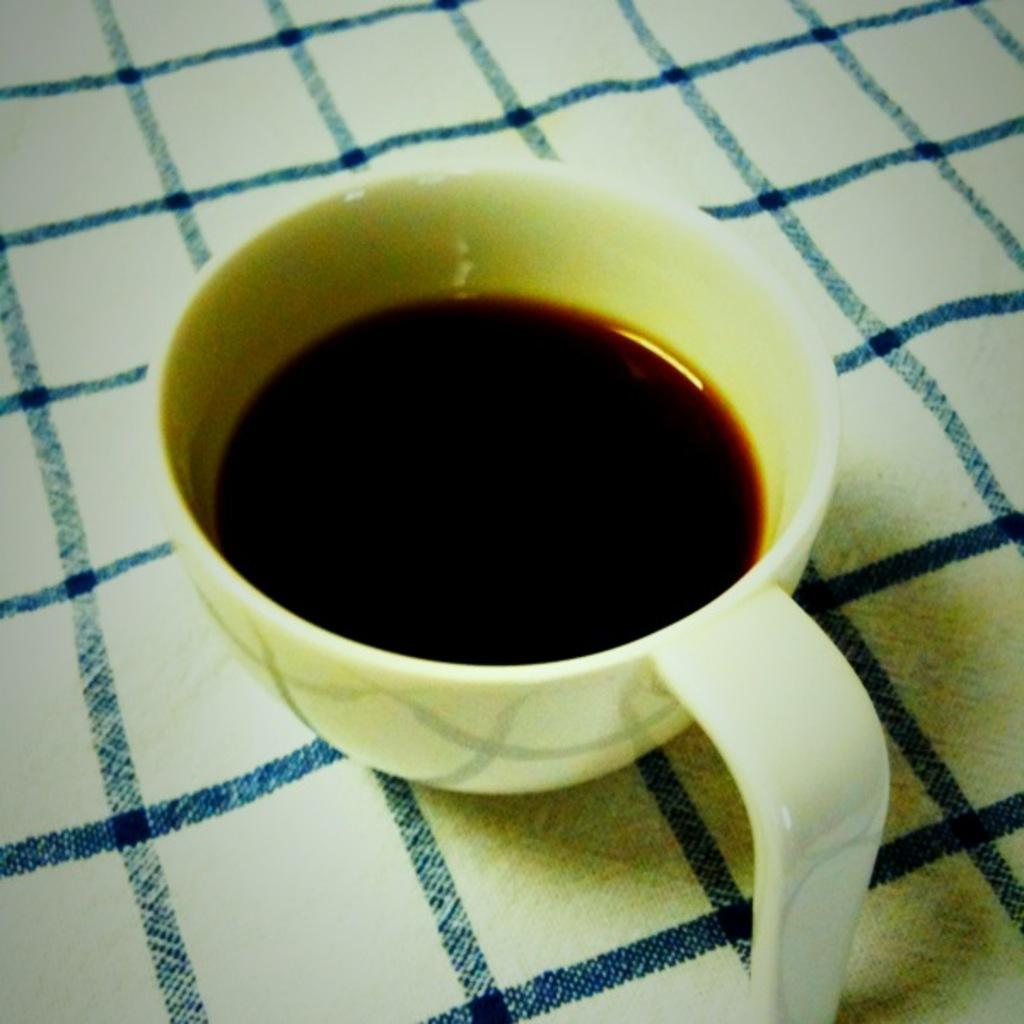What is in the cup that is visible in the image? There is a cup with black tea in it. Where is the cup placed in the image? The cup is placed on a table. How many boots are visible in the image? There are no boots present in the image. What type of dinner is being served in the image? There is no dinner present in the image; it only features a cup with black tea. 